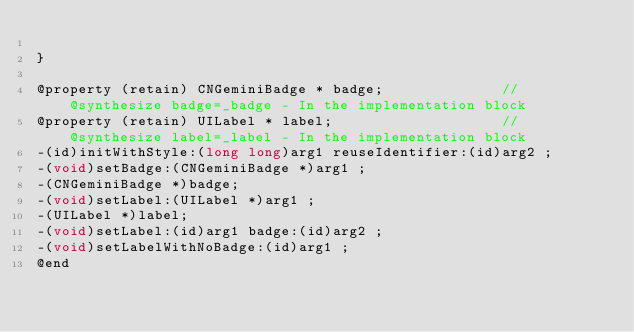<code> <loc_0><loc_0><loc_500><loc_500><_C_>
}

@property (retain) CNGeminiBadge * badge;              //@synthesize badge=_badge - In the implementation block
@property (retain) UILabel * label;                    //@synthesize label=_label - In the implementation block
-(id)initWithStyle:(long long)arg1 reuseIdentifier:(id)arg2 ;
-(void)setBadge:(CNGeminiBadge *)arg1 ;
-(CNGeminiBadge *)badge;
-(void)setLabel:(UILabel *)arg1 ;
-(UILabel *)label;
-(void)setLabel:(id)arg1 badge:(id)arg2 ;
-(void)setLabelWithNoBadge:(id)arg1 ;
@end

</code> 